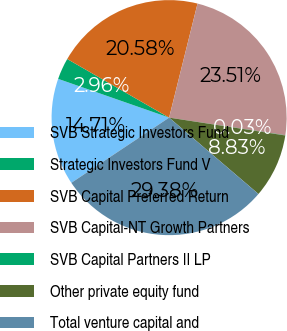Convert chart. <chart><loc_0><loc_0><loc_500><loc_500><pie_chart><fcel>SVB Strategic Investors Fund<fcel>Strategic Investors Fund V<fcel>SVB Capital Preferred Return<fcel>SVB Capital-NT Growth Partners<fcel>SVB Capital Partners II LP<fcel>Other private equity fund<fcel>Total venture capital and<nl><fcel>14.71%<fcel>2.96%<fcel>20.58%<fcel>23.51%<fcel>0.03%<fcel>8.83%<fcel>29.38%<nl></chart> 